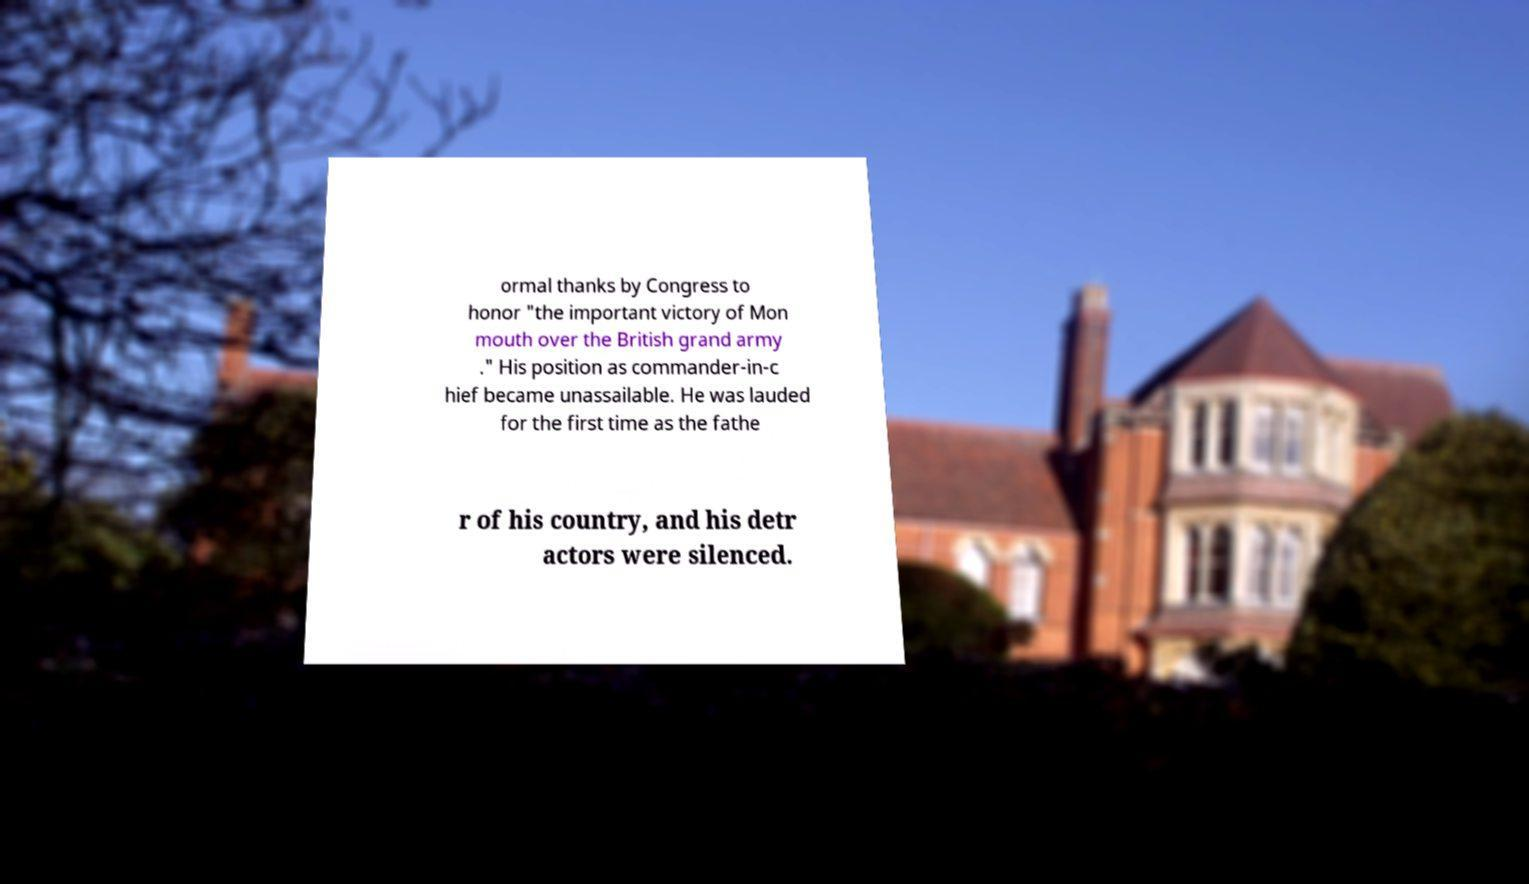Can you read and provide the text displayed in the image?This photo seems to have some interesting text. Can you extract and type it out for me? ormal thanks by Congress to honor "the important victory of Mon mouth over the British grand army ." His position as commander-in-c hief became unassailable. He was lauded for the first time as the fathe r of his country, and his detr actors were silenced. 